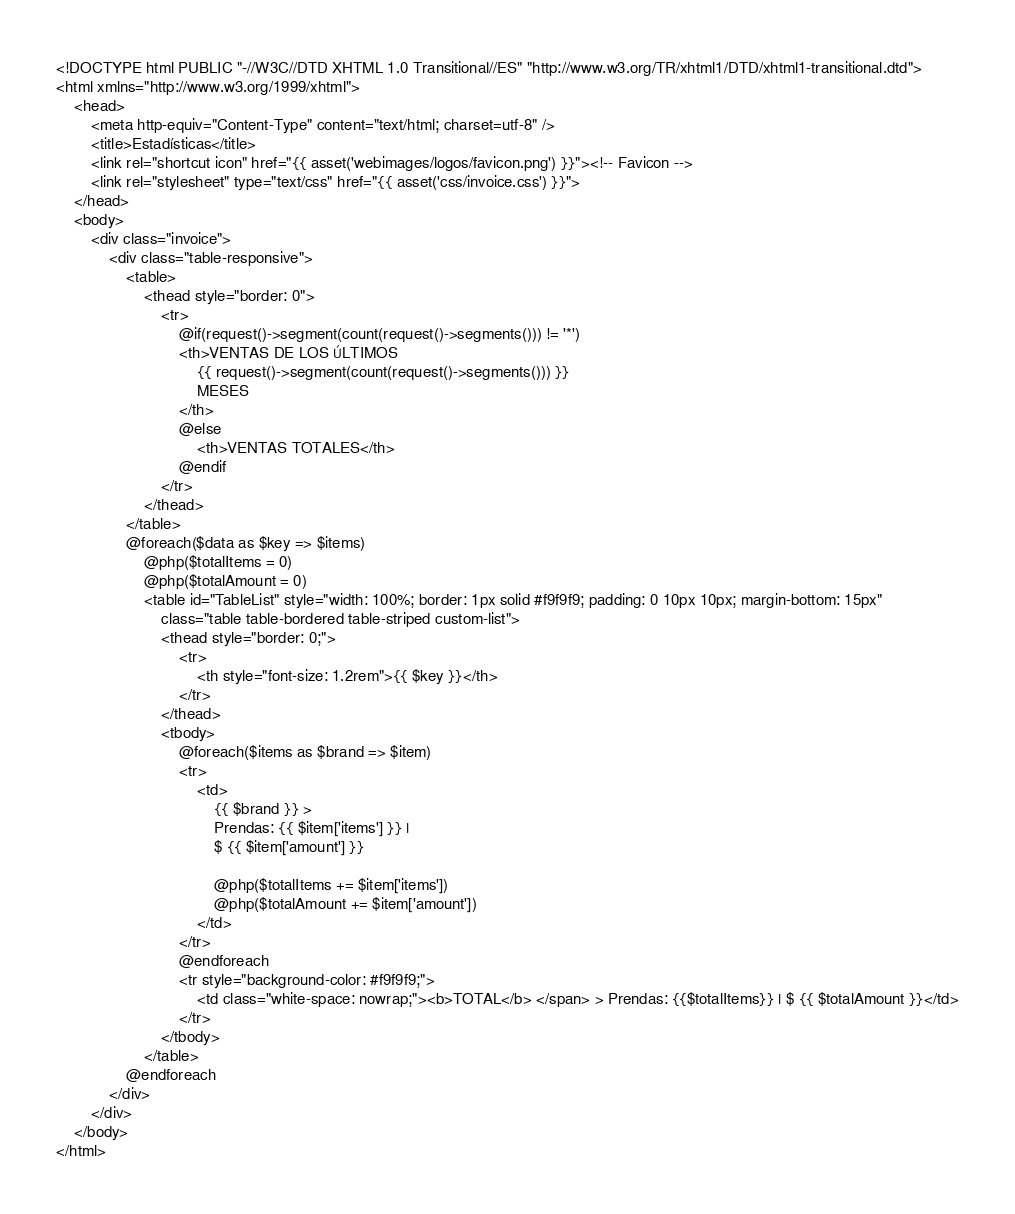<code> <loc_0><loc_0><loc_500><loc_500><_PHP_><!DOCTYPE html PUBLIC "-//W3C//DTD XHTML 1.0 Transitional//ES" "http://www.w3.org/TR/xhtml1/DTD/xhtml1-transitional.dtd">
<html xmlns="http://www.w3.org/1999/xhtml">
    <head>
        <meta http-equiv="Content-Type" content="text/html; charset=utf-8" />
        <title>Estadísticas</title>
        <link rel="shortcut icon" href="{{ asset('webimages/logos/favicon.png') }}"><!-- Favicon -->
        <link rel="stylesheet" type="text/css" href="{{ asset('css/invoice.css') }}">
    </head>
    <body>
        <div class="invoice">
            <div class="table-responsive">
                <table>
                    <thead style="border: 0">
                        <tr>
                            @if(request()->segment(count(request()->segments())) != '*')
                            <th>VENTAS DE LOS ÚLTIMOS  
                                {{ request()->segment(count(request()->segments())) }}
                                MESES
                            </th>
                            @else
                                <th>VENTAS TOTALES</th>
                            @endif
                        </tr>
                    </thead>
                </table>
                @foreach($data as $key => $items)
                    @php($totalItems = 0)
                    @php($totalAmount = 0)
                    <table id="TableList" style="width: 100%; border: 1px solid #f9f9f9; padding: 0 10px 10px; margin-bottom: 15px"
                        class="table table-bordered table-striped custom-list">
                        <thead style="border: 0;">
                            <tr>
                                <th style="font-size: 1.2rem">{{ $key }}</th>
                            </tr>
                        </thead>
                        <tbody>
                            @foreach($items as $brand => $item)
                            <tr>    
                                <td>
                                    {{ $brand }} > 
                                    Prendas: {{ $item['items'] }} | 
                                    $ {{ $item['amount'] }}

                                    @php($totalItems += $item['items'])
                                    @php($totalAmount += $item['amount'])
                                </td>    
                            </tr> 
                            @endforeach
                            <tr style="background-color: #f9f9f9;">
                                <td class="white-space: nowrap;"><b>TOTAL</b> </span> > Prendas: {{$totalItems}} | $ {{ $totalAmount }}</td>
                            </tr> 
                        </tbody>
                    </table>
                @endforeach
            </div>
        </div>
    </body>
</html></code> 